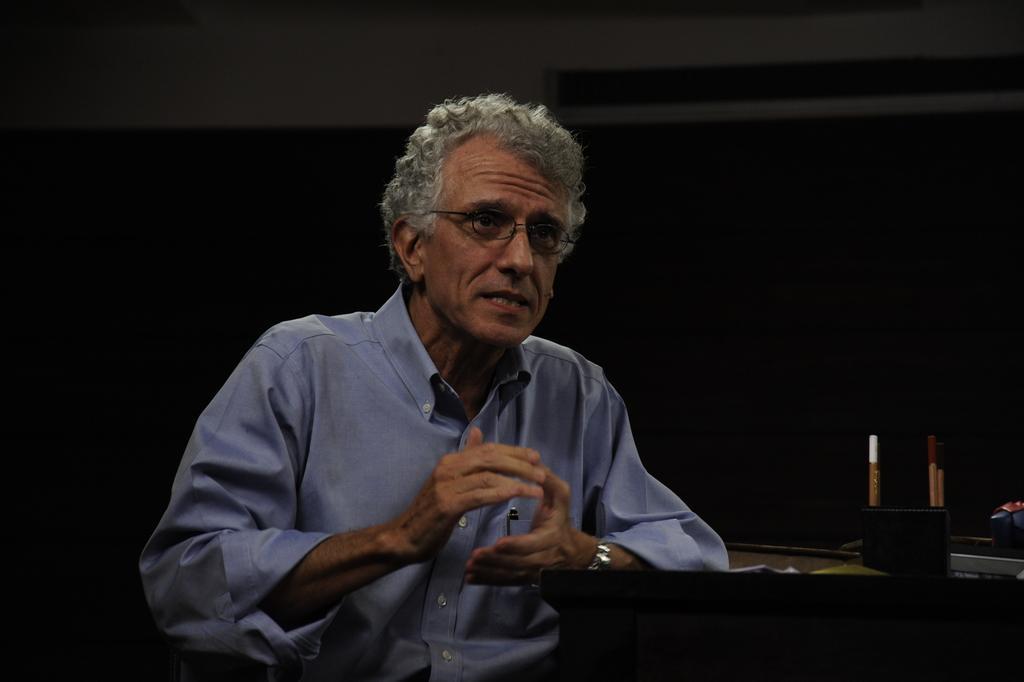Could you give a brief overview of what you see in this image? In this picture I can see a man sitting and a pen stand on the table and I can see a dark background. 